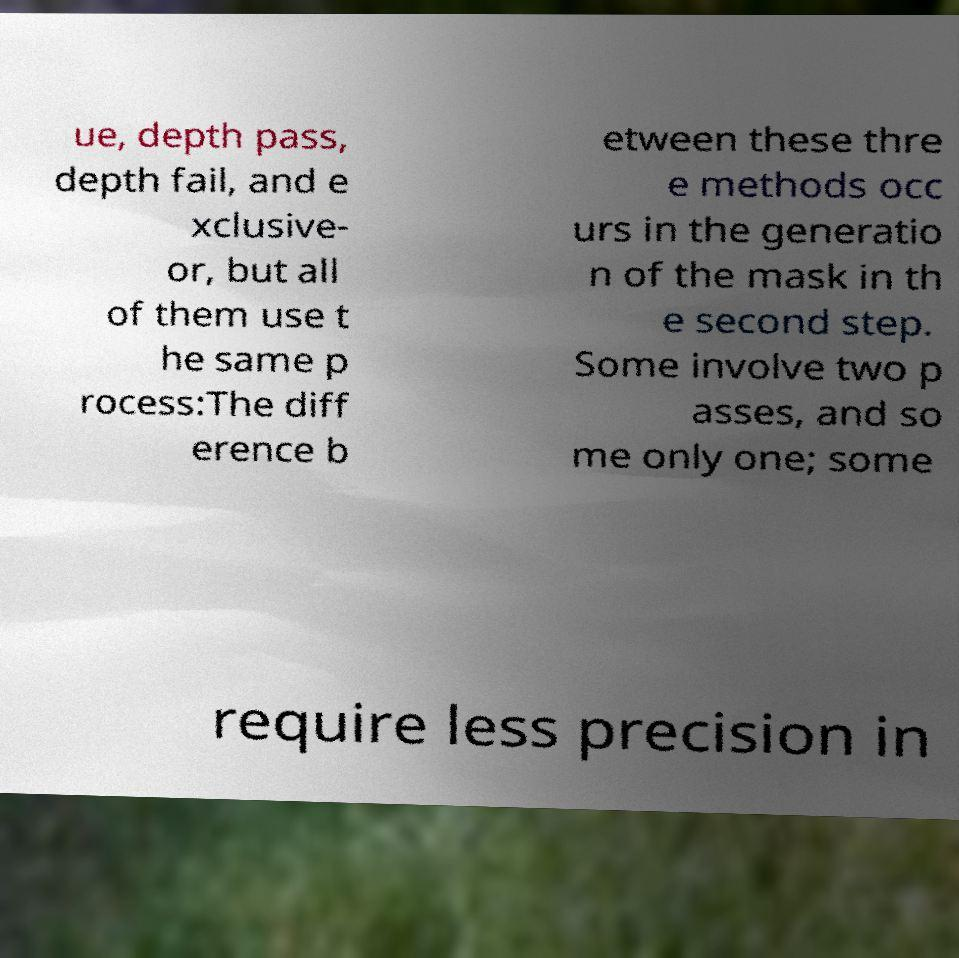Please read and relay the text visible in this image. What does it say? ue, depth pass, depth fail, and e xclusive- or, but all of them use t he same p rocess:The diff erence b etween these thre e methods occ urs in the generatio n of the mask in th e second step. Some involve two p asses, and so me only one; some require less precision in 